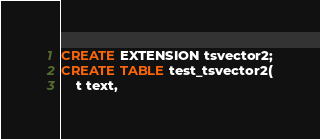Convert code to text. <code><loc_0><loc_0><loc_500><loc_500><_SQL_>CREATE EXTENSION tsvector2;
CREATE TABLE test_tsvector2(
	t text,</code> 